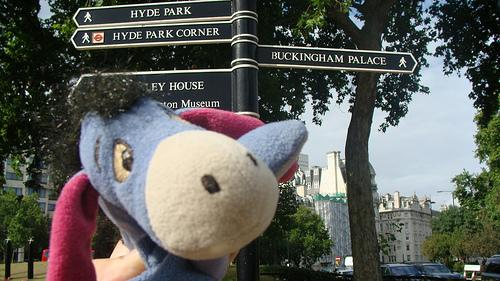Comment on the quality of the image in terms of composition and clarity. The image has good composition and clarity, with the stuffed Eeyore toy contrasting the street signs and the urban background for visual interest. How many street signs can be identified within the image, and where do they point? There are three major street signs in the image, pointing towards Buckingham Palace, Hyde Park, and Hyde Park Corner. Analyze the sentiment portrayed by the Eeyore toy held in the image. The Eeyore toy portrays a sad and gloomy sentiment, with its droopy and melancholic facial expression. Identify the type of interaction happening between the person holding the Eeyore toy and the surrounding environment. The person holding the Eeyore toy is playfully presenting it in front of the street signs as if the toy is exploring and experiencing the London landmarks. Describe the setting of the image in terms of location and environment. The image is set in London, England, near landmarks such as Buckingham Palace and Hyde Park, featuring an urban environment with cars, trees, and street signs. Provide a brief overview of the scene captured in the image. A stuffed Eeyore toy is being held up in front of multiple street signs in London, pointing towards Buckingham Palace and Hyde Park, with cars and trees in the background. List the objects in the image that are mounted on poles. Street signs, a black metal pole, and a streetlight are mounted on poles in the image. Explain which city this image is likely taken in and provide evidence from the image. The image is likely taken in London, England, as the street signs point to landmarks such as Buckingham Palace, Hyde Park, and Hyde Park Corner. Identify the primary object being held in the image and describe its appearance. The primary object is a stuffed Eeyore toy, featuring blue fur, pink ears, and a melancholic expression. Count the number of visible cars in the image. There are at least two cars visible in the image, parked along the street. Provide a brief description of the event captured in the image. A person holding a stuffed Eeyore in front of street signs in London. What are the colors of the poles where the signs are mounted? Black and white stripes What type of stuffed animal is seen in the image? Eeyore Identify any multi-modal creation occurring in the image. A person's hand holding a stuffed Eeyore toy against a backdrop of a pole with street signs. What type of vehicle is parked on the right side of the image? Cars Describe the main object in the image being held by a hand. A stuffed Eeyore toy is being held by a hand. Is there a building visible in the image and where is it located compared to the street signs? Yes, there is a building in the distance behind the street signs. Explain what Eeyore is doing in the image. Eeyore is being held up by a hand in front of street signs. Which way is Buckingham Palace according to the signs in the image? To the right Can you identify the red sign pointing to Buckingham Palace? No, it's not mentioned in the image. Where is the playground located in the park? There is a park mentioned in the image, but no mention of a playground inside it. Do you see a group of people standing under the streetlight behind the trees? There is a streetlight behind the trees, but no mention of people standing under it. Write a caption for the image describing the stuffed animal and a prominent street sign. Hand holding up a stuffed Eeyore toy with street signs pointing to Hyde Park and Buckingham Palace. Describe the physical characteristics of the pole with street signs. Black metal pole with multiple street signs attached pointing to various locations. Is there a dog playing in the grassy area of the park? There is a grassy area in the park, but no mention of a dog playing in it. In this image, which sign is pointing to Buckingham Palace and is there any emblem on it?  The sign pointing to Buckingham Palace has a person emblem on it. Which iconic London park is displayed on a sign in the image? Hyde Park Where are the bicycles next to the cars parked along the street? There are cars parked along the street, but no mention of bicycles being there. What are the two primary locations mentioned on the signs in the image? Hyde Park and Buckingham Palace Is there a tree trunk visible in the picture and what kind of object is behind it? Yes, there is a tree trunk and a streetlight is behind it. Does the stuffed animal have pink ears? Yes Mention a road sign that is visible in the image and the location it is pointing to. Sign pointing to Hyde Park Corner Point out the position of the white stripes on a pole in the image. The white stripes are located towards the top of the pole. 